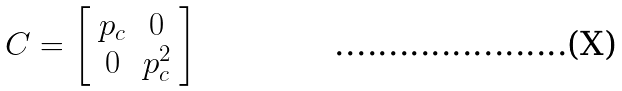<formula> <loc_0><loc_0><loc_500><loc_500>C = \left [ \begin{array} { c c } p _ { c } & 0 \\ 0 & p _ { c } ^ { 2 } \end{array} \right ]</formula> 